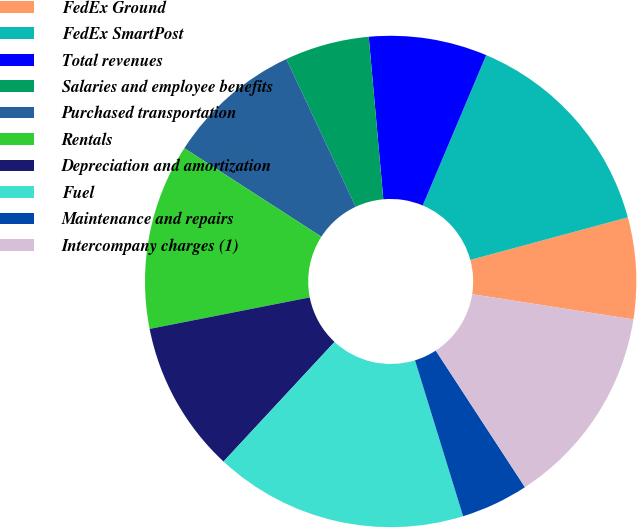<chart> <loc_0><loc_0><loc_500><loc_500><pie_chart><fcel>FedEx Ground<fcel>FedEx SmartPost<fcel>Total revenues<fcel>Salaries and employee benefits<fcel>Purchased transportation<fcel>Rentals<fcel>Depreciation and amortization<fcel>Fuel<fcel>Maintenance and repairs<fcel>Intercompany charges (1)<nl><fcel>6.67%<fcel>14.44%<fcel>7.78%<fcel>5.56%<fcel>8.89%<fcel>12.22%<fcel>10.0%<fcel>16.67%<fcel>4.44%<fcel>13.33%<nl></chart> 